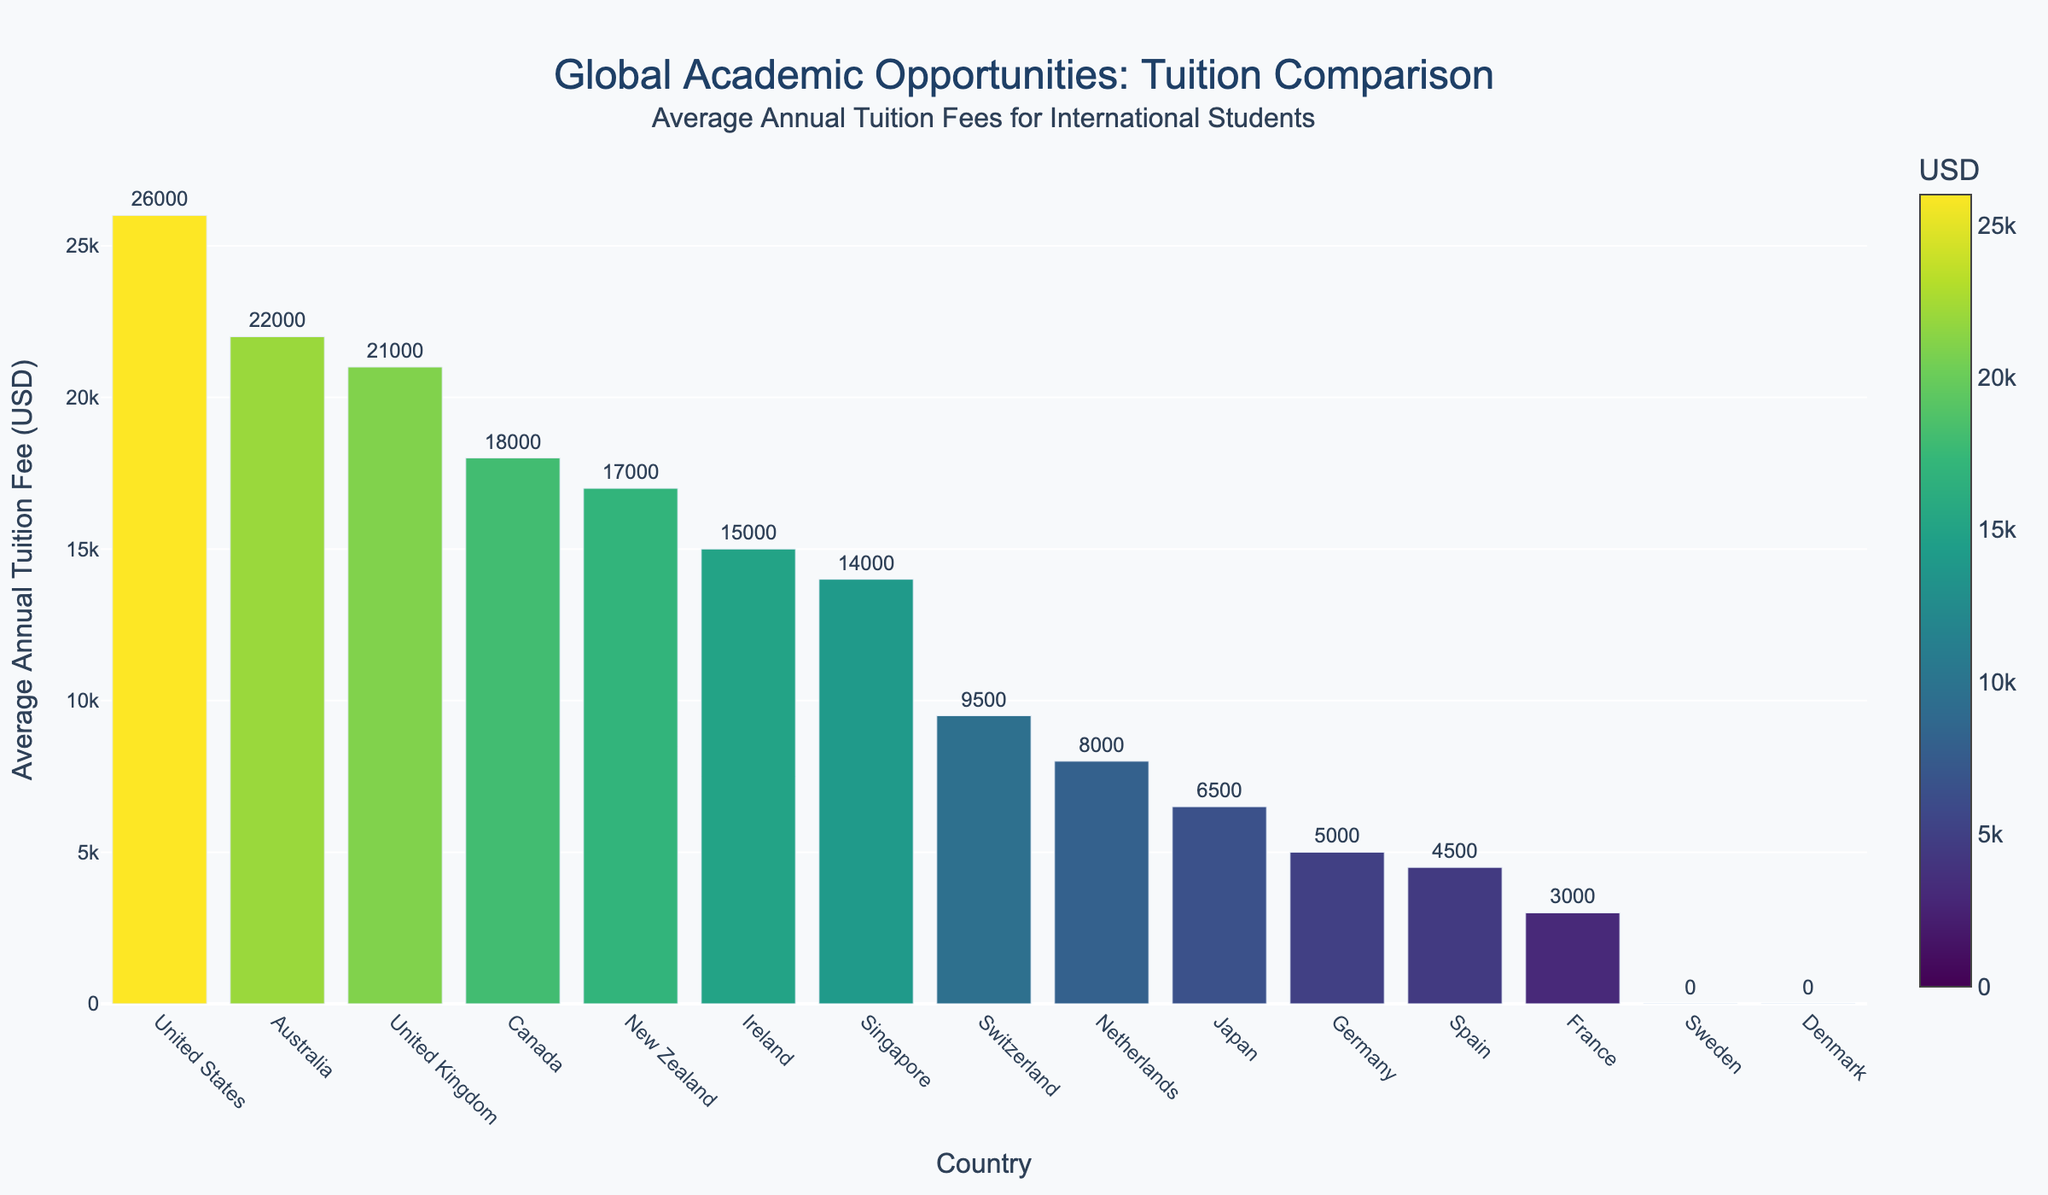Which country has the highest average annual tuition fee for international students? By referring to the highest bar in the figure, we can identify the country with the highest average annual tuition fee. The United States has the highest bar, indicating the highest fee.
Answer: United States Which two countries have zero tuition fees for international students? By looking for the countries with bars of zero height, we can identify that Sweden and Denmark have no tuition fees.
Answer: Sweden and Denmark What is the difference between the average tuition fees in the United States and Germany? The average tuition fee in the United States is USD 26,000, and in Germany, it is USD 5,000. The difference is calculated as 26,000 - 5,000 = 21,000.
Answer: 21,000 What is the combined average annual tuition fee for international students in France and Spain? France has an average tuition fee of USD 3,000 and Spain has USD 4,500. The combined fee is calculated by adding these values: 3,000 + 4,500 = 7,500.
Answer: 7,500 How much higher is the tuition fee in the United Kingdom compared to Japan? The average tuition fee in the United Kingdom is USD 21,000, and in Japan it's USD 6,500. The difference is 21,000 - 6,500 = 14,500.
Answer: 14,500 Which country appears to be most affordable (other than those with zero tuition) for international students? By identifying the smallest bar that is greater than zero, we see that France has the lowest average annual tuition fee of USD 3,000, making it the most affordable.
Answer: France What is the range of the tuition fees shown in the figure? The range is the difference between the highest and lowest non-zero tuition fees. The highest is USD 26,000 (United States) and the lowest non-zero is USD 3,000 (France), so the range is 26,000 - 3,000 = 23,000.
Answer: 23,000 What are the average annual tuition fees for international students in Canada and New Zealand, and how do they compare? Canada has an average annual tuition fee of USD 18,000, while New Zealand has USD 17,000. Comparing the two, Canada has a higher fee by 18,000 - 17,000 = 1,000.
Answer: Canada: 18,000, New Zealand: 17,000, Difference: 1,000 Which country has the closest average annual tuition fee to the global average (considering the countries provided)? Calculating the global average first:
(26,000 + 21,000 + 22,000 + 18,000 + 5,000 + 3,000 + 8,000 + 6,500 + 14,000 + 17,000 + 9,500 + 0 + 0 + 15,000 + 4,500) / 15 ≈ 12,433.33. The country closest to this average is Singapore with USD 14,000.
Answer: Singapore 